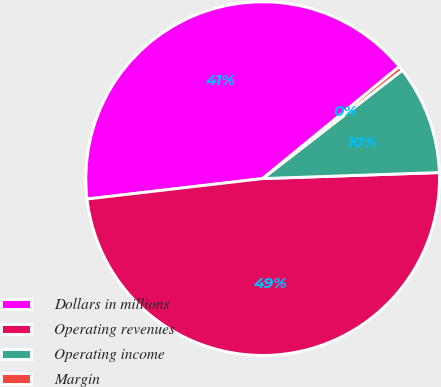Convert chart to OTSL. <chart><loc_0><loc_0><loc_500><loc_500><pie_chart><fcel>Dollars in millions<fcel>Operating revenues<fcel>Operating income<fcel>Margin<nl><fcel>40.92%<fcel>48.7%<fcel>9.96%<fcel>0.42%<nl></chart> 